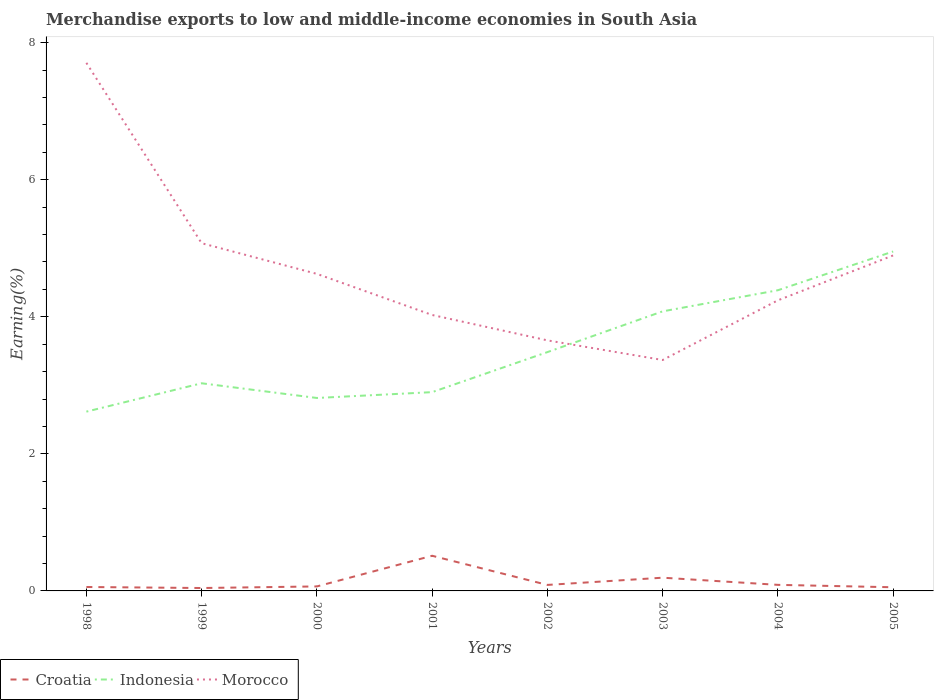Is the number of lines equal to the number of legend labels?
Offer a terse response. Yes. Across all years, what is the maximum percentage of amount earned from merchandise exports in Indonesia?
Ensure brevity in your answer.  2.62. What is the total percentage of amount earned from merchandise exports in Morocco in the graph?
Make the answer very short. 0.29. What is the difference between the highest and the second highest percentage of amount earned from merchandise exports in Morocco?
Provide a succinct answer. 4.34. What is the difference between the highest and the lowest percentage of amount earned from merchandise exports in Croatia?
Your answer should be compact. 2. Is the percentage of amount earned from merchandise exports in Indonesia strictly greater than the percentage of amount earned from merchandise exports in Croatia over the years?
Ensure brevity in your answer.  No. How many lines are there?
Provide a short and direct response. 3. How many years are there in the graph?
Your response must be concise. 8. Where does the legend appear in the graph?
Offer a terse response. Bottom left. How are the legend labels stacked?
Provide a short and direct response. Horizontal. What is the title of the graph?
Your answer should be compact. Merchandise exports to low and middle-income economies in South Asia. What is the label or title of the X-axis?
Ensure brevity in your answer.  Years. What is the label or title of the Y-axis?
Your response must be concise. Earning(%). What is the Earning(%) in Croatia in 1998?
Ensure brevity in your answer.  0.06. What is the Earning(%) of Indonesia in 1998?
Offer a terse response. 2.62. What is the Earning(%) of Morocco in 1998?
Make the answer very short. 7.71. What is the Earning(%) of Croatia in 1999?
Make the answer very short. 0.04. What is the Earning(%) of Indonesia in 1999?
Provide a succinct answer. 3.03. What is the Earning(%) in Morocco in 1999?
Provide a short and direct response. 5.07. What is the Earning(%) of Croatia in 2000?
Your response must be concise. 0.07. What is the Earning(%) of Indonesia in 2000?
Make the answer very short. 2.82. What is the Earning(%) of Morocco in 2000?
Ensure brevity in your answer.  4.63. What is the Earning(%) in Croatia in 2001?
Ensure brevity in your answer.  0.51. What is the Earning(%) in Indonesia in 2001?
Keep it short and to the point. 2.9. What is the Earning(%) of Morocco in 2001?
Provide a succinct answer. 4.03. What is the Earning(%) in Croatia in 2002?
Give a very brief answer. 0.09. What is the Earning(%) of Indonesia in 2002?
Your response must be concise. 3.48. What is the Earning(%) of Morocco in 2002?
Provide a short and direct response. 3.66. What is the Earning(%) of Croatia in 2003?
Give a very brief answer. 0.19. What is the Earning(%) of Indonesia in 2003?
Your answer should be very brief. 4.08. What is the Earning(%) of Morocco in 2003?
Make the answer very short. 3.37. What is the Earning(%) of Croatia in 2004?
Your answer should be compact. 0.09. What is the Earning(%) in Indonesia in 2004?
Your answer should be compact. 4.39. What is the Earning(%) in Morocco in 2004?
Offer a very short reply. 4.24. What is the Earning(%) of Croatia in 2005?
Ensure brevity in your answer.  0.05. What is the Earning(%) in Indonesia in 2005?
Your answer should be very brief. 4.95. What is the Earning(%) in Morocco in 2005?
Your response must be concise. 4.9. Across all years, what is the maximum Earning(%) in Croatia?
Make the answer very short. 0.51. Across all years, what is the maximum Earning(%) in Indonesia?
Offer a terse response. 4.95. Across all years, what is the maximum Earning(%) in Morocco?
Give a very brief answer. 7.71. Across all years, what is the minimum Earning(%) in Croatia?
Your response must be concise. 0.04. Across all years, what is the minimum Earning(%) of Indonesia?
Provide a short and direct response. 2.62. Across all years, what is the minimum Earning(%) of Morocco?
Provide a succinct answer. 3.37. What is the total Earning(%) of Croatia in the graph?
Provide a succinct answer. 1.1. What is the total Earning(%) of Indonesia in the graph?
Give a very brief answer. 28.27. What is the total Earning(%) in Morocco in the graph?
Make the answer very short. 37.6. What is the difference between the Earning(%) of Croatia in 1998 and that in 1999?
Provide a succinct answer. 0.01. What is the difference between the Earning(%) of Indonesia in 1998 and that in 1999?
Give a very brief answer. -0.41. What is the difference between the Earning(%) in Morocco in 1998 and that in 1999?
Provide a short and direct response. 2.63. What is the difference between the Earning(%) in Croatia in 1998 and that in 2000?
Your answer should be compact. -0.01. What is the difference between the Earning(%) in Indonesia in 1998 and that in 2000?
Your answer should be compact. -0.2. What is the difference between the Earning(%) in Morocco in 1998 and that in 2000?
Keep it short and to the point. 3.08. What is the difference between the Earning(%) of Croatia in 1998 and that in 2001?
Your answer should be very brief. -0.46. What is the difference between the Earning(%) of Indonesia in 1998 and that in 2001?
Keep it short and to the point. -0.28. What is the difference between the Earning(%) of Morocco in 1998 and that in 2001?
Offer a terse response. 3.68. What is the difference between the Earning(%) in Croatia in 1998 and that in 2002?
Your response must be concise. -0.03. What is the difference between the Earning(%) of Indonesia in 1998 and that in 2002?
Your answer should be compact. -0.87. What is the difference between the Earning(%) in Morocco in 1998 and that in 2002?
Offer a terse response. 4.05. What is the difference between the Earning(%) in Croatia in 1998 and that in 2003?
Keep it short and to the point. -0.14. What is the difference between the Earning(%) in Indonesia in 1998 and that in 2003?
Give a very brief answer. -1.46. What is the difference between the Earning(%) in Morocco in 1998 and that in 2003?
Your answer should be compact. 4.34. What is the difference between the Earning(%) of Croatia in 1998 and that in 2004?
Your answer should be very brief. -0.03. What is the difference between the Earning(%) in Indonesia in 1998 and that in 2004?
Offer a terse response. -1.77. What is the difference between the Earning(%) of Morocco in 1998 and that in 2004?
Offer a terse response. 3.47. What is the difference between the Earning(%) of Croatia in 1998 and that in 2005?
Provide a short and direct response. 0. What is the difference between the Earning(%) in Indonesia in 1998 and that in 2005?
Your answer should be very brief. -2.34. What is the difference between the Earning(%) of Morocco in 1998 and that in 2005?
Offer a terse response. 2.81. What is the difference between the Earning(%) in Croatia in 1999 and that in 2000?
Your response must be concise. -0.02. What is the difference between the Earning(%) of Indonesia in 1999 and that in 2000?
Offer a terse response. 0.21. What is the difference between the Earning(%) in Morocco in 1999 and that in 2000?
Give a very brief answer. 0.45. What is the difference between the Earning(%) in Croatia in 1999 and that in 2001?
Give a very brief answer. -0.47. What is the difference between the Earning(%) of Indonesia in 1999 and that in 2001?
Make the answer very short. 0.13. What is the difference between the Earning(%) of Morocco in 1999 and that in 2001?
Provide a succinct answer. 1.05. What is the difference between the Earning(%) of Croatia in 1999 and that in 2002?
Your response must be concise. -0.05. What is the difference between the Earning(%) of Indonesia in 1999 and that in 2002?
Keep it short and to the point. -0.45. What is the difference between the Earning(%) of Morocco in 1999 and that in 2002?
Give a very brief answer. 1.42. What is the difference between the Earning(%) of Croatia in 1999 and that in 2003?
Keep it short and to the point. -0.15. What is the difference between the Earning(%) of Indonesia in 1999 and that in 2003?
Give a very brief answer. -1.05. What is the difference between the Earning(%) in Morocco in 1999 and that in 2003?
Your answer should be compact. 1.7. What is the difference between the Earning(%) of Croatia in 1999 and that in 2004?
Offer a very short reply. -0.05. What is the difference between the Earning(%) of Indonesia in 1999 and that in 2004?
Offer a terse response. -1.36. What is the difference between the Earning(%) of Morocco in 1999 and that in 2004?
Your answer should be very brief. 0.83. What is the difference between the Earning(%) of Croatia in 1999 and that in 2005?
Make the answer very short. -0.01. What is the difference between the Earning(%) in Indonesia in 1999 and that in 2005?
Your response must be concise. -1.92. What is the difference between the Earning(%) in Morocco in 1999 and that in 2005?
Give a very brief answer. 0.18. What is the difference between the Earning(%) in Croatia in 2000 and that in 2001?
Your answer should be very brief. -0.45. What is the difference between the Earning(%) in Indonesia in 2000 and that in 2001?
Offer a terse response. -0.09. What is the difference between the Earning(%) in Morocco in 2000 and that in 2001?
Give a very brief answer. 0.6. What is the difference between the Earning(%) in Croatia in 2000 and that in 2002?
Provide a short and direct response. -0.02. What is the difference between the Earning(%) in Indonesia in 2000 and that in 2002?
Your answer should be compact. -0.67. What is the difference between the Earning(%) in Morocco in 2000 and that in 2002?
Provide a short and direct response. 0.97. What is the difference between the Earning(%) of Croatia in 2000 and that in 2003?
Your answer should be very brief. -0.13. What is the difference between the Earning(%) in Indonesia in 2000 and that in 2003?
Ensure brevity in your answer.  -1.26. What is the difference between the Earning(%) of Morocco in 2000 and that in 2003?
Your answer should be compact. 1.26. What is the difference between the Earning(%) of Croatia in 2000 and that in 2004?
Provide a short and direct response. -0.02. What is the difference between the Earning(%) in Indonesia in 2000 and that in 2004?
Your answer should be compact. -1.57. What is the difference between the Earning(%) of Morocco in 2000 and that in 2004?
Your answer should be very brief. 0.39. What is the difference between the Earning(%) in Croatia in 2000 and that in 2005?
Offer a very short reply. 0.01. What is the difference between the Earning(%) of Indonesia in 2000 and that in 2005?
Offer a very short reply. -2.14. What is the difference between the Earning(%) in Morocco in 2000 and that in 2005?
Ensure brevity in your answer.  -0.27. What is the difference between the Earning(%) in Croatia in 2001 and that in 2002?
Give a very brief answer. 0.43. What is the difference between the Earning(%) of Indonesia in 2001 and that in 2002?
Make the answer very short. -0.58. What is the difference between the Earning(%) of Morocco in 2001 and that in 2002?
Your answer should be compact. 0.37. What is the difference between the Earning(%) of Croatia in 2001 and that in 2003?
Ensure brevity in your answer.  0.32. What is the difference between the Earning(%) of Indonesia in 2001 and that in 2003?
Offer a terse response. -1.18. What is the difference between the Earning(%) of Morocco in 2001 and that in 2003?
Keep it short and to the point. 0.66. What is the difference between the Earning(%) of Croatia in 2001 and that in 2004?
Provide a succinct answer. 0.42. What is the difference between the Earning(%) in Indonesia in 2001 and that in 2004?
Provide a short and direct response. -1.49. What is the difference between the Earning(%) in Morocco in 2001 and that in 2004?
Offer a terse response. -0.21. What is the difference between the Earning(%) in Croatia in 2001 and that in 2005?
Your answer should be very brief. 0.46. What is the difference between the Earning(%) of Indonesia in 2001 and that in 2005?
Your answer should be compact. -2.05. What is the difference between the Earning(%) in Morocco in 2001 and that in 2005?
Give a very brief answer. -0.87. What is the difference between the Earning(%) in Croatia in 2002 and that in 2003?
Keep it short and to the point. -0.11. What is the difference between the Earning(%) of Indonesia in 2002 and that in 2003?
Your response must be concise. -0.59. What is the difference between the Earning(%) in Morocco in 2002 and that in 2003?
Provide a succinct answer. 0.29. What is the difference between the Earning(%) in Croatia in 2002 and that in 2004?
Provide a succinct answer. -0. What is the difference between the Earning(%) of Indonesia in 2002 and that in 2004?
Provide a short and direct response. -0.9. What is the difference between the Earning(%) of Morocco in 2002 and that in 2004?
Provide a succinct answer. -0.58. What is the difference between the Earning(%) in Croatia in 2002 and that in 2005?
Provide a short and direct response. 0.03. What is the difference between the Earning(%) in Indonesia in 2002 and that in 2005?
Provide a short and direct response. -1.47. What is the difference between the Earning(%) in Morocco in 2002 and that in 2005?
Offer a very short reply. -1.24. What is the difference between the Earning(%) of Croatia in 2003 and that in 2004?
Offer a very short reply. 0.1. What is the difference between the Earning(%) of Indonesia in 2003 and that in 2004?
Give a very brief answer. -0.31. What is the difference between the Earning(%) in Morocco in 2003 and that in 2004?
Offer a terse response. -0.87. What is the difference between the Earning(%) of Croatia in 2003 and that in 2005?
Your response must be concise. 0.14. What is the difference between the Earning(%) of Indonesia in 2003 and that in 2005?
Your answer should be very brief. -0.87. What is the difference between the Earning(%) of Morocco in 2003 and that in 2005?
Provide a succinct answer. -1.53. What is the difference between the Earning(%) of Croatia in 2004 and that in 2005?
Give a very brief answer. 0.04. What is the difference between the Earning(%) of Indonesia in 2004 and that in 2005?
Your answer should be compact. -0.57. What is the difference between the Earning(%) of Morocco in 2004 and that in 2005?
Give a very brief answer. -0.66. What is the difference between the Earning(%) in Croatia in 1998 and the Earning(%) in Indonesia in 1999?
Your response must be concise. -2.97. What is the difference between the Earning(%) of Croatia in 1998 and the Earning(%) of Morocco in 1999?
Make the answer very short. -5.02. What is the difference between the Earning(%) of Indonesia in 1998 and the Earning(%) of Morocco in 1999?
Keep it short and to the point. -2.46. What is the difference between the Earning(%) in Croatia in 1998 and the Earning(%) in Indonesia in 2000?
Ensure brevity in your answer.  -2.76. What is the difference between the Earning(%) in Croatia in 1998 and the Earning(%) in Morocco in 2000?
Offer a very short reply. -4.57. What is the difference between the Earning(%) in Indonesia in 1998 and the Earning(%) in Morocco in 2000?
Keep it short and to the point. -2.01. What is the difference between the Earning(%) in Croatia in 1998 and the Earning(%) in Indonesia in 2001?
Your answer should be compact. -2.84. What is the difference between the Earning(%) in Croatia in 1998 and the Earning(%) in Morocco in 2001?
Offer a very short reply. -3.97. What is the difference between the Earning(%) in Indonesia in 1998 and the Earning(%) in Morocco in 2001?
Offer a very short reply. -1.41. What is the difference between the Earning(%) in Croatia in 1998 and the Earning(%) in Indonesia in 2002?
Make the answer very short. -3.43. What is the difference between the Earning(%) of Croatia in 1998 and the Earning(%) of Morocco in 2002?
Provide a short and direct response. -3.6. What is the difference between the Earning(%) of Indonesia in 1998 and the Earning(%) of Morocco in 2002?
Keep it short and to the point. -1.04. What is the difference between the Earning(%) of Croatia in 1998 and the Earning(%) of Indonesia in 2003?
Ensure brevity in your answer.  -4.02. What is the difference between the Earning(%) in Croatia in 1998 and the Earning(%) in Morocco in 2003?
Make the answer very short. -3.31. What is the difference between the Earning(%) of Indonesia in 1998 and the Earning(%) of Morocco in 2003?
Your answer should be very brief. -0.75. What is the difference between the Earning(%) of Croatia in 1998 and the Earning(%) of Indonesia in 2004?
Ensure brevity in your answer.  -4.33. What is the difference between the Earning(%) in Croatia in 1998 and the Earning(%) in Morocco in 2004?
Offer a terse response. -4.18. What is the difference between the Earning(%) in Indonesia in 1998 and the Earning(%) in Morocco in 2004?
Make the answer very short. -1.62. What is the difference between the Earning(%) in Croatia in 1998 and the Earning(%) in Indonesia in 2005?
Your answer should be very brief. -4.9. What is the difference between the Earning(%) in Croatia in 1998 and the Earning(%) in Morocco in 2005?
Ensure brevity in your answer.  -4.84. What is the difference between the Earning(%) in Indonesia in 1998 and the Earning(%) in Morocco in 2005?
Give a very brief answer. -2.28. What is the difference between the Earning(%) in Croatia in 1999 and the Earning(%) in Indonesia in 2000?
Give a very brief answer. -2.77. What is the difference between the Earning(%) in Croatia in 1999 and the Earning(%) in Morocco in 2000?
Your answer should be very brief. -4.58. What is the difference between the Earning(%) in Indonesia in 1999 and the Earning(%) in Morocco in 2000?
Your response must be concise. -1.6. What is the difference between the Earning(%) of Croatia in 1999 and the Earning(%) of Indonesia in 2001?
Your response must be concise. -2.86. What is the difference between the Earning(%) in Croatia in 1999 and the Earning(%) in Morocco in 2001?
Your response must be concise. -3.98. What is the difference between the Earning(%) in Indonesia in 1999 and the Earning(%) in Morocco in 2001?
Your response must be concise. -1. What is the difference between the Earning(%) in Croatia in 1999 and the Earning(%) in Indonesia in 2002?
Your answer should be very brief. -3.44. What is the difference between the Earning(%) in Croatia in 1999 and the Earning(%) in Morocco in 2002?
Provide a succinct answer. -3.61. What is the difference between the Earning(%) of Indonesia in 1999 and the Earning(%) of Morocco in 2002?
Your answer should be compact. -0.63. What is the difference between the Earning(%) in Croatia in 1999 and the Earning(%) in Indonesia in 2003?
Offer a very short reply. -4.04. What is the difference between the Earning(%) of Croatia in 1999 and the Earning(%) of Morocco in 2003?
Your answer should be very brief. -3.33. What is the difference between the Earning(%) in Indonesia in 1999 and the Earning(%) in Morocco in 2003?
Provide a succinct answer. -0.34. What is the difference between the Earning(%) in Croatia in 1999 and the Earning(%) in Indonesia in 2004?
Ensure brevity in your answer.  -4.35. What is the difference between the Earning(%) of Croatia in 1999 and the Earning(%) of Morocco in 2004?
Provide a short and direct response. -4.2. What is the difference between the Earning(%) in Indonesia in 1999 and the Earning(%) in Morocco in 2004?
Give a very brief answer. -1.21. What is the difference between the Earning(%) in Croatia in 1999 and the Earning(%) in Indonesia in 2005?
Keep it short and to the point. -4.91. What is the difference between the Earning(%) of Croatia in 1999 and the Earning(%) of Morocco in 2005?
Keep it short and to the point. -4.85. What is the difference between the Earning(%) in Indonesia in 1999 and the Earning(%) in Morocco in 2005?
Ensure brevity in your answer.  -1.87. What is the difference between the Earning(%) in Croatia in 2000 and the Earning(%) in Indonesia in 2001?
Offer a very short reply. -2.84. What is the difference between the Earning(%) in Croatia in 2000 and the Earning(%) in Morocco in 2001?
Provide a succinct answer. -3.96. What is the difference between the Earning(%) in Indonesia in 2000 and the Earning(%) in Morocco in 2001?
Offer a very short reply. -1.21. What is the difference between the Earning(%) of Croatia in 2000 and the Earning(%) of Indonesia in 2002?
Keep it short and to the point. -3.42. What is the difference between the Earning(%) in Croatia in 2000 and the Earning(%) in Morocco in 2002?
Offer a terse response. -3.59. What is the difference between the Earning(%) in Indonesia in 2000 and the Earning(%) in Morocco in 2002?
Your answer should be very brief. -0.84. What is the difference between the Earning(%) of Croatia in 2000 and the Earning(%) of Indonesia in 2003?
Keep it short and to the point. -4.01. What is the difference between the Earning(%) in Croatia in 2000 and the Earning(%) in Morocco in 2003?
Provide a short and direct response. -3.3. What is the difference between the Earning(%) in Indonesia in 2000 and the Earning(%) in Morocco in 2003?
Make the answer very short. -0.55. What is the difference between the Earning(%) in Croatia in 2000 and the Earning(%) in Indonesia in 2004?
Ensure brevity in your answer.  -4.32. What is the difference between the Earning(%) in Croatia in 2000 and the Earning(%) in Morocco in 2004?
Keep it short and to the point. -4.18. What is the difference between the Earning(%) in Indonesia in 2000 and the Earning(%) in Morocco in 2004?
Give a very brief answer. -1.43. What is the difference between the Earning(%) of Croatia in 2000 and the Earning(%) of Indonesia in 2005?
Keep it short and to the point. -4.89. What is the difference between the Earning(%) of Croatia in 2000 and the Earning(%) of Morocco in 2005?
Keep it short and to the point. -4.83. What is the difference between the Earning(%) of Indonesia in 2000 and the Earning(%) of Morocco in 2005?
Your answer should be very brief. -2.08. What is the difference between the Earning(%) in Croatia in 2001 and the Earning(%) in Indonesia in 2002?
Ensure brevity in your answer.  -2.97. What is the difference between the Earning(%) of Croatia in 2001 and the Earning(%) of Morocco in 2002?
Your response must be concise. -3.14. What is the difference between the Earning(%) in Indonesia in 2001 and the Earning(%) in Morocco in 2002?
Keep it short and to the point. -0.76. What is the difference between the Earning(%) of Croatia in 2001 and the Earning(%) of Indonesia in 2003?
Your answer should be compact. -3.57. What is the difference between the Earning(%) of Croatia in 2001 and the Earning(%) of Morocco in 2003?
Make the answer very short. -2.86. What is the difference between the Earning(%) in Indonesia in 2001 and the Earning(%) in Morocco in 2003?
Your response must be concise. -0.47. What is the difference between the Earning(%) of Croatia in 2001 and the Earning(%) of Indonesia in 2004?
Provide a succinct answer. -3.88. What is the difference between the Earning(%) of Croatia in 2001 and the Earning(%) of Morocco in 2004?
Provide a short and direct response. -3.73. What is the difference between the Earning(%) of Indonesia in 2001 and the Earning(%) of Morocco in 2004?
Provide a succinct answer. -1.34. What is the difference between the Earning(%) in Croatia in 2001 and the Earning(%) in Indonesia in 2005?
Ensure brevity in your answer.  -4.44. What is the difference between the Earning(%) in Croatia in 2001 and the Earning(%) in Morocco in 2005?
Keep it short and to the point. -4.38. What is the difference between the Earning(%) of Indonesia in 2001 and the Earning(%) of Morocco in 2005?
Offer a terse response. -2. What is the difference between the Earning(%) of Croatia in 2002 and the Earning(%) of Indonesia in 2003?
Make the answer very short. -3.99. What is the difference between the Earning(%) of Croatia in 2002 and the Earning(%) of Morocco in 2003?
Provide a short and direct response. -3.28. What is the difference between the Earning(%) of Indonesia in 2002 and the Earning(%) of Morocco in 2003?
Provide a short and direct response. 0.12. What is the difference between the Earning(%) in Croatia in 2002 and the Earning(%) in Indonesia in 2004?
Offer a terse response. -4.3. What is the difference between the Earning(%) of Croatia in 2002 and the Earning(%) of Morocco in 2004?
Keep it short and to the point. -4.15. What is the difference between the Earning(%) of Indonesia in 2002 and the Earning(%) of Morocco in 2004?
Ensure brevity in your answer.  -0.76. What is the difference between the Earning(%) of Croatia in 2002 and the Earning(%) of Indonesia in 2005?
Provide a short and direct response. -4.87. What is the difference between the Earning(%) of Croatia in 2002 and the Earning(%) of Morocco in 2005?
Your response must be concise. -4.81. What is the difference between the Earning(%) of Indonesia in 2002 and the Earning(%) of Morocco in 2005?
Your answer should be compact. -1.41. What is the difference between the Earning(%) in Croatia in 2003 and the Earning(%) in Indonesia in 2004?
Your answer should be very brief. -4.19. What is the difference between the Earning(%) of Croatia in 2003 and the Earning(%) of Morocco in 2004?
Provide a short and direct response. -4.05. What is the difference between the Earning(%) in Indonesia in 2003 and the Earning(%) in Morocco in 2004?
Ensure brevity in your answer.  -0.16. What is the difference between the Earning(%) in Croatia in 2003 and the Earning(%) in Indonesia in 2005?
Your answer should be compact. -4.76. What is the difference between the Earning(%) in Croatia in 2003 and the Earning(%) in Morocco in 2005?
Your response must be concise. -4.7. What is the difference between the Earning(%) in Indonesia in 2003 and the Earning(%) in Morocco in 2005?
Your answer should be compact. -0.82. What is the difference between the Earning(%) in Croatia in 2004 and the Earning(%) in Indonesia in 2005?
Keep it short and to the point. -4.86. What is the difference between the Earning(%) in Croatia in 2004 and the Earning(%) in Morocco in 2005?
Provide a succinct answer. -4.81. What is the difference between the Earning(%) of Indonesia in 2004 and the Earning(%) of Morocco in 2005?
Your answer should be compact. -0.51. What is the average Earning(%) in Croatia per year?
Provide a succinct answer. 0.14. What is the average Earning(%) in Indonesia per year?
Give a very brief answer. 3.53. What is the average Earning(%) of Morocco per year?
Your response must be concise. 4.7. In the year 1998, what is the difference between the Earning(%) in Croatia and Earning(%) in Indonesia?
Ensure brevity in your answer.  -2.56. In the year 1998, what is the difference between the Earning(%) of Croatia and Earning(%) of Morocco?
Your answer should be compact. -7.65. In the year 1998, what is the difference between the Earning(%) in Indonesia and Earning(%) in Morocco?
Offer a terse response. -5.09. In the year 1999, what is the difference between the Earning(%) of Croatia and Earning(%) of Indonesia?
Your response must be concise. -2.99. In the year 1999, what is the difference between the Earning(%) in Croatia and Earning(%) in Morocco?
Offer a very short reply. -5.03. In the year 1999, what is the difference between the Earning(%) of Indonesia and Earning(%) of Morocco?
Give a very brief answer. -2.04. In the year 2000, what is the difference between the Earning(%) of Croatia and Earning(%) of Indonesia?
Your response must be concise. -2.75. In the year 2000, what is the difference between the Earning(%) of Croatia and Earning(%) of Morocco?
Your answer should be compact. -4.56. In the year 2000, what is the difference between the Earning(%) of Indonesia and Earning(%) of Morocco?
Provide a short and direct response. -1.81. In the year 2001, what is the difference between the Earning(%) in Croatia and Earning(%) in Indonesia?
Your response must be concise. -2.39. In the year 2001, what is the difference between the Earning(%) of Croatia and Earning(%) of Morocco?
Offer a very short reply. -3.51. In the year 2001, what is the difference between the Earning(%) in Indonesia and Earning(%) in Morocco?
Provide a succinct answer. -1.13. In the year 2002, what is the difference between the Earning(%) of Croatia and Earning(%) of Indonesia?
Your answer should be compact. -3.4. In the year 2002, what is the difference between the Earning(%) in Croatia and Earning(%) in Morocco?
Your answer should be very brief. -3.57. In the year 2002, what is the difference between the Earning(%) in Indonesia and Earning(%) in Morocco?
Offer a very short reply. -0.17. In the year 2003, what is the difference between the Earning(%) of Croatia and Earning(%) of Indonesia?
Keep it short and to the point. -3.89. In the year 2003, what is the difference between the Earning(%) in Croatia and Earning(%) in Morocco?
Your response must be concise. -3.18. In the year 2003, what is the difference between the Earning(%) in Indonesia and Earning(%) in Morocco?
Offer a very short reply. 0.71. In the year 2004, what is the difference between the Earning(%) in Croatia and Earning(%) in Indonesia?
Your answer should be compact. -4.3. In the year 2004, what is the difference between the Earning(%) of Croatia and Earning(%) of Morocco?
Give a very brief answer. -4.15. In the year 2004, what is the difference between the Earning(%) of Indonesia and Earning(%) of Morocco?
Offer a terse response. 0.15. In the year 2005, what is the difference between the Earning(%) of Croatia and Earning(%) of Indonesia?
Ensure brevity in your answer.  -4.9. In the year 2005, what is the difference between the Earning(%) in Croatia and Earning(%) in Morocco?
Your answer should be compact. -4.84. In the year 2005, what is the difference between the Earning(%) in Indonesia and Earning(%) in Morocco?
Keep it short and to the point. 0.06. What is the ratio of the Earning(%) of Croatia in 1998 to that in 1999?
Provide a succinct answer. 1.35. What is the ratio of the Earning(%) of Indonesia in 1998 to that in 1999?
Your answer should be compact. 0.86. What is the ratio of the Earning(%) of Morocco in 1998 to that in 1999?
Make the answer very short. 1.52. What is the ratio of the Earning(%) in Croatia in 1998 to that in 2000?
Ensure brevity in your answer.  0.87. What is the ratio of the Earning(%) in Indonesia in 1998 to that in 2000?
Your answer should be compact. 0.93. What is the ratio of the Earning(%) of Morocco in 1998 to that in 2000?
Provide a short and direct response. 1.67. What is the ratio of the Earning(%) of Croatia in 1998 to that in 2001?
Offer a terse response. 0.11. What is the ratio of the Earning(%) in Indonesia in 1998 to that in 2001?
Provide a succinct answer. 0.9. What is the ratio of the Earning(%) of Morocco in 1998 to that in 2001?
Offer a very short reply. 1.91. What is the ratio of the Earning(%) in Croatia in 1998 to that in 2002?
Your answer should be compact. 0.65. What is the ratio of the Earning(%) in Indonesia in 1998 to that in 2002?
Provide a succinct answer. 0.75. What is the ratio of the Earning(%) of Morocco in 1998 to that in 2002?
Provide a short and direct response. 2.11. What is the ratio of the Earning(%) of Croatia in 1998 to that in 2003?
Make the answer very short. 0.3. What is the ratio of the Earning(%) in Indonesia in 1998 to that in 2003?
Keep it short and to the point. 0.64. What is the ratio of the Earning(%) in Morocco in 1998 to that in 2003?
Provide a short and direct response. 2.29. What is the ratio of the Earning(%) in Croatia in 1998 to that in 2004?
Give a very brief answer. 0.65. What is the ratio of the Earning(%) in Indonesia in 1998 to that in 2004?
Give a very brief answer. 0.6. What is the ratio of the Earning(%) in Morocco in 1998 to that in 2004?
Your answer should be compact. 1.82. What is the ratio of the Earning(%) of Croatia in 1998 to that in 2005?
Your response must be concise. 1.07. What is the ratio of the Earning(%) of Indonesia in 1998 to that in 2005?
Make the answer very short. 0.53. What is the ratio of the Earning(%) of Morocco in 1998 to that in 2005?
Offer a terse response. 1.57. What is the ratio of the Earning(%) of Croatia in 1999 to that in 2000?
Your answer should be very brief. 0.65. What is the ratio of the Earning(%) in Indonesia in 1999 to that in 2000?
Offer a very short reply. 1.08. What is the ratio of the Earning(%) of Morocco in 1999 to that in 2000?
Your answer should be very brief. 1.1. What is the ratio of the Earning(%) in Croatia in 1999 to that in 2001?
Your response must be concise. 0.08. What is the ratio of the Earning(%) of Indonesia in 1999 to that in 2001?
Ensure brevity in your answer.  1.04. What is the ratio of the Earning(%) in Morocco in 1999 to that in 2001?
Provide a short and direct response. 1.26. What is the ratio of the Earning(%) of Croatia in 1999 to that in 2002?
Provide a succinct answer. 0.48. What is the ratio of the Earning(%) in Indonesia in 1999 to that in 2002?
Ensure brevity in your answer.  0.87. What is the ratio of the Earning(%) of Morocco in 1999 to that in 2002?
Give a very brief answer. 1.39. What is the ratio of the Earning(%) in Croatia in 1999 to that in 2003?
Offer a terse response. 0.22. What is the ratio of the Earning(%) in Indonesia in 1999 to that in 2003?
Keep it short and to the point. 0.74. What is the ratio of the Earning(%) of Morocco in 1999 to that in 2003?
Offer a terse response. 1.51. What is the ratio of the Earning(%) in Croatia in 1999 to that in 2004?
Make the answer very short. 0.48. What is the ratio of the Earning(%) of Indonesia in 1999 to that in 2004?
Give a very brief answer. 0.69. What is the ratio of the Earning(%) in Morocco in 1999 to that in 2004?
Ensure brevity in your answer.  1.2. What is the ratio of the Earning(%) in Croatia in 1999 to that in 2005?
Provide a short and direct response. 0.79. What is the ratio of the Earning(%) of Indonesia in 1999 to that in 2005?
Offer a terse response. 0.61. What is the ratio of the Earning(%) of Morocco in 1999 to that in 2005?
Your answer should be very brief. 1.04. What is the ratio of the Earning(%) of Croatia in 2000 to that in 2001?
Ensure brevity in your answer.  0.13. What is the ratio of the Earning(%) in Indonesia in 2000 to that in 2001?
Make the answer very short. 0.97. What is the ratio of the Earning(%) of Morocco in 2000 to that in 2001?
Provide a short and direct response. 1.15. What is the ratio of the Earning(%) of Croatia in 2000 to that in 2002?
Offer a very short reply. 0.75. What is the ratio of the Earning(%) of Indonesia in 2000 to that in 2002?
Your response must be concise. 0.81. What is the ratio of the Earning(%) of Morocco in 2000 to that in 2002?
Give a very brief answer. 1.27. What is the ratio of the Earning(%) of Croatia in 2000 to that in 2003?
Make the answer very short. 0.34. What is the ratio of the Earning(%) of Indonesia in 2000 to that in 2003?
Your answer should be very brief. 0.69. What is the ratio of the Earning(%) of Morocco in 2000 to that in 2003?
Your response must be concise. 1.37. What is the ratio of the Earning(%) of Croatia in 2000 to that in 2004?
Your answer should be compact. 0.74. What is the ratio of the Earning(%) of Indonesia in 2000 to that in 2004?
Provide a short and direct response. 0.64. What is the ratio of the Earning(%) of Morocco in 2000 to that in 2004?
Your answer should be very brief. 1.09. What is the ratio of the Earning(%) of Croatia in 2000 to that in 2005?
Offer a very short reply. 1.23. What is the ratio of the Earning(%) of Indonesia in 2000 to that in 2005?
Your answer should be compact. 0.57. What is the ratio of the Earning(%) in Morocco in 2000 to that in 2005?
Ensure brevity in your answer.  0.94. What is the ratio of the Earning(%) in Croatia in 2001 to that in 2002?
Provide a succinct answer. 5.86. What is the ratio of the Earning(%) in Indonesia in 2001 to that in 2002?
Offer a terse response. 0.83. What is the ratio of the Earning(%) in Morocco in 2001 to that in 2002?
Ensure brevity in your answer.  1.1. What is the ratio of the Earning(%) of Croatia in 2001 to that in 2003?
Keep it short and to the point. 2.66. What is the ratio of the Earning(%) of Indonesia in 2001 to that in 2003?
Provide a short and direct response. 0.71. What is the ratio of the Earning(%) of Morocco in 2001 to that in 2003?
Make the answer very short. 1.2. What is the ratio of the Earning(%) of Croatia in 2001 to that in 2004?
Offer a very short reply. 5.79. What is the ratio of the Earning(%) of Indonesia in 2001 to that in 2004?
Give a very brief answer. 0.66. What is the ratio of the Earning(%) of Morocco in 2001 to that in 2004?
Your response must be concise. 0.95. What is the ratio of the Earning(%) of Croatia in 2001 to that in 2005?
Provide a succinct answer. 9.59. What is the ratio of the Earning(%) in Indonesia in 2001 to that in 2005?
Offer a terse response. 0.59. What is the ratio of the Earning(%) in Morocco in 2001 to that in 2005?
Make the answer very short. 0.82. What is the ratio of the Earning(%) of Croatia in 2002 to that in 2003?
Your response must be concise. 0.45. What is the ratio of the Earning(%) of Indonesia in 2002 to that in 2003?
Offer a very short reply. 0.85. What is the ratio of the Earning(%) in Morocco in 2002 to that in 2003?
Provide a short and direct response. 1.08. What is the ratio of the Earning(%) in Croatia in 2002 to that in 2004?
Offer a terse response. 0.99. What is the ratio of the Earning(%) in Indonesia in 2002 to that in 2004?
Offer a very short reply. 0.79. What is the ratio of the Earning(%) of Morocco in 2002 to that in 2004?
Keep it short and to the point. 0.86. What is the ratio of the Earning(%) in Croatia in 2002 to that in 2005?
Ensure brevity in your answer.  1.64. What is the ratio of the Earning(%) of Indonesia in 2002 to that in 2005?
Provide a short and direct response. 0.7. What is the ratio of the Earning(%) of Morocco in 2002 to that in 2005?
Provide a succinct answer. 0.75. What is the ratio of the Earning(%) in Croatia in 2003 to that in 2004?
Keep it short and to the point. 2.18. What is the ratio of the Earning(%) in Indonesia in 2003 to that in 2004?
Your answer should be compact. 0.93. What is the ratio of the Earning(%) of Morocco in 2003 to that in 2004?
Provide a succinct answer. 0.79. What is the ratio of the Earning(%) in Croatia in 2003 to that in 2005?
Make the answer very short. 3.61. What is the ratio of the Earning(%) of Indonesia in 2003 to that in 2005?
Ensure brevity in your answer.  0.82. What is the ratio of the Earning(%) of Morocco in 2003 to that in 2005?
Offer a terse response. 0.69. What is the ratio of the Earning(%) of Croatia in 2004 to that in 2005?
Offer a terse response. 1.65. What is the ratio of the Earning(%) of Indonesia in 2004 to that in 2005?
Offer a very short reply. 0.89. What is the ratio of the Earning(%) of Morocco in 2004 to that in 2005?
Make the answer very short. 0.87. What is the difference between the highest and the second highest Earning(%) in Croatia?
Make the answer very short. 0.32. What is the difference between the highest and the second highest Earning(%) of Indonesia?
Provide a short and direct response. 0.57. What is the difference between the highest and the second highest Earning(%) in Morocco?
Ensure brevity in your answer.  2.63. What is the difference between the highest and the lowest Earning(%) of Croatia?
Provide a short and direct response. 0.47. What is the difference between the highest and the lowest Earning(%) in Indonesia?
Your answer should be compact. 2.34. What is the difference between the highest and the lowest Earning(%) of Morocco?
Your answer should be compact. 4.34. 